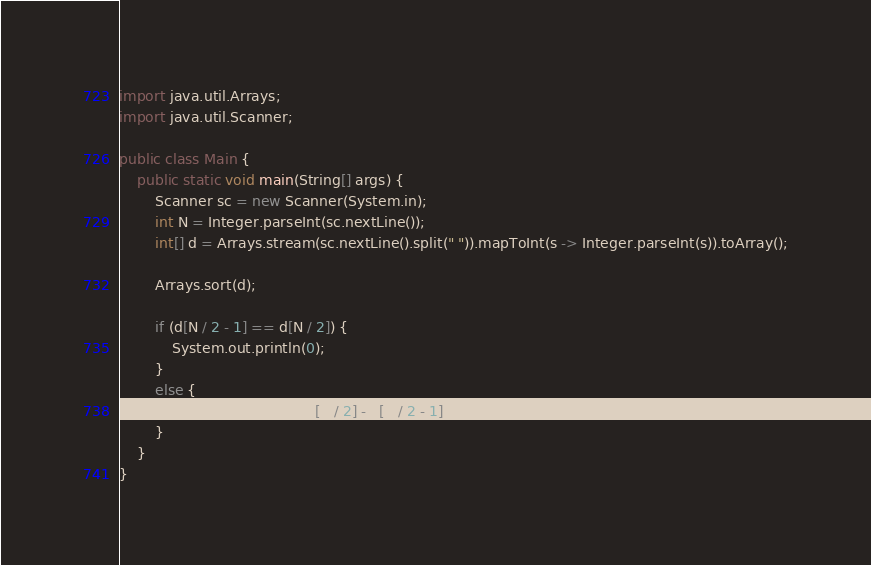Convert code to text. <code><loc_0><loc_0><loc_500><loc_500><_Java_>import java.util.Arrays;
import java.util.Scanner;

public class Main {
	public static void main(String[] args) {
		Scanner sc = new Scanner(System.in);
		int N = Integer.parseInt(sc.nextLine());
		int[] d = Arrays.stream(sc.nextLine().split(" ")).mapToInt(s -> Integer.parseInt(s)).toArray();

		Arrays.sort(d);

		if (d[N / 2 - 1] == d[N / 2]) {
			System.out.println(0);
		}
		else {
			System.out.println(d[N / 2] - d[N / 2 - 1]);
		}
	}
}</code> 